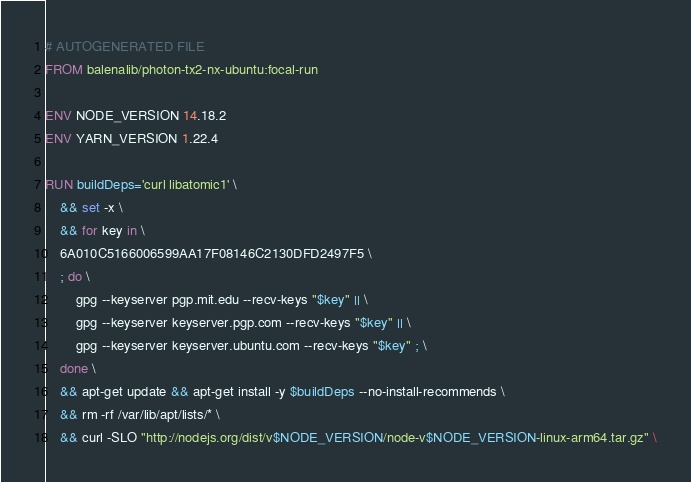Convert code to text. <code><loc_0><loc_0><loc_500><loc_500><_Dockerfile_># AUTOGENERATED FILE
FROM balenalib/photon-tx2-nx-ubuntu:focal-run

ENV NODE_VERSION 14.18.2
ENV YARN_VERSION 1.22.4

RUN buildDeps='curl libatomic1' \
	&& set -x \
	&& for key in \
	6A010C5166006599AA17F08146C2130DFD2497F5 \
	; do \
		gpg --keyserver pgp.mit.edu --recv-keys "$key" || \
		gpg --keyserver keyserver.pgp.com --recv-keys "$key" || \
		gpg --keyserver keyserver.ubuntu.com --recv-keys "$key" ; \
	done \
	&& apt-get update && apt-get install -y $buildDeps --no-install-recommends \
	&& rm -rf /var/lib/apt/lists/* \
	&& curl -SLO "http://nodejs.org/dist/v$NODE_VERSION/node-v$NODE_VERSION-linux-arm64.tar.gz" \</code> 